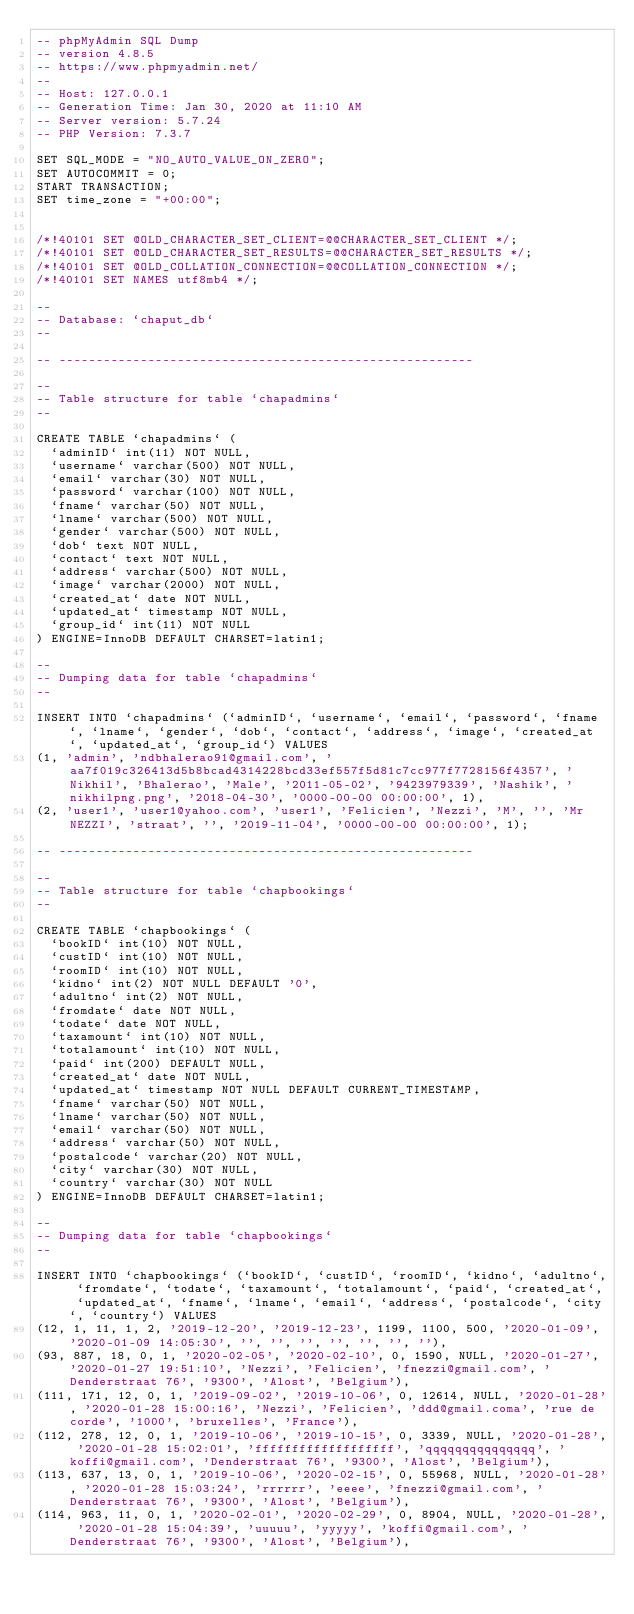<code> <loc_0><loc_0><loc_500><loc_500><_SQL_>-- phpMyAdmin SQL Dump
-- version 4.8.5
-- https://www.phpmyadmin.net/
--
-- Host: 127.0.0.1
-- Generation Time: Jan 30, 2020 at 11:10 AM
-- Server version: 5.7.24
-- PHP Version: 7.3.7

SET SQL_MODE = "NO_AUTO_VALUE_ON_ZERO";
SET AUTOCOMMIT = 0;
START TRANSACTION;
SET time_zone = "+00:00";


/*!40101 SET @OLD_CHARACTER_SET_CLIENT=@@CHARACTER_SET_CLIENT */;
/*!40101 SET @OLD_CHARACTER_SET_RESULTS=@@CHARACTER_SET_RESULTS */;
/*!40101 SET @OLD_COLLATION_CONNECTION=@@COLLATION_CONNECTION */;
/*!40101 SET NAMES utf8mb4 */;

--
-- Database: `chaput_db`
--

-- --------------------------------------------------------

--
-- Table structure for table `chapadmins`
--

CREATE TABLE `chapadmins` (
  `adminID` int(11) NOT NULL,
  `username` varchar(500) NOT NULL,
  `email` varchar(30) NOT NULL,
  `password` varchar(100) NOT NULL,
  `fname` varchar(50) NOT NULL,
  `lname` varchar(500) NOT NULL,
  `gender` varchar(500) NOT NULL,
  `dob` text NOT NULL,
  `contact` text NOT NULL,
  `address` varchar(500) NOT NULL,
  `image` varchar(2000) NOT NULL,
  `created_at` date NOT NULL,
  `updated_at` timestamp NOT NULL,
  `group_id` int(11) NOT NULL
) ENGINE=InnoDB DEFAULT CHARSET=latin1;

--
-- Dumping data for table `chapadmins`
--

INSERT INTO `chapadmins` (`adminID`, `username`, `email`, `password`, `fname`, `lname`, `gender`, `dob`, `contact`, `address`, `image`, `created_at`, `updated_at`, `group_id`) VALUES
(1, 'admin', 'ndbhalerao91@gmail.com', 'aa7f019c326413d5b8bcad4314228bcd33ef557f5d81c7cc977f7728156f4357', 'Nikhil', 'Bhalerao', 'Male', '2011-05-02', '9423979339', 'Nashik', 'nikhilpng.png', '2018-04-30', '0000-00-00 00:00:00', 1),
(2, 'user1', 'user1@yahoo.com', 'user1', 'Felicien', 'Nezzi', 'M', '', 'Mr NEZZI', 'straat', '', '2019-11-04', '0000-00-00 00:00:00', 1);

-- --------------------------------------------------------

--
-- Table structure for table `chapbookings`
--

CREATE TABLE `chapbookings` (
  `bookID` int(10) NOT NULL,
  `custID` int(10) NOT NULL,
  `roomID` int(10) NOT NULL,
  `kidno` int(2) NOT NULL DEFAULT '0',
  `adultno` int(2) NOT NULL,
  `fromdate` date NOT NULL,
  `todate` date NOT NULL,
  `taxamount` int(10) NOT NULL,
  `totalamount` int(10) NOT NULL,
  `paid` int(200) DEFAULT NULL,
  `created_at` date NOT NULL,
  `updated_at` timestamp NOT NULL DEFAULT CURRENT_TIMESTAMP,
  `fname` varchar(50) NOT NULL,
  `lname` varchar(50) NOT NULL,
  `email` varchar(50) NOT NULL,
  `address` varchar(50) NOT NULL,
  `postalcode` varchar(20) NOT NULL,
  `city` varchar(30) NOT NULL,
  `country` varchar(30) NOT NULL
) ENGINE=InnoDB DEFAULT CHARSET=latin1;

--
-- Dumping data for table `chapbookings`
--

INSERT INTO `chapbookings` (`bookID`, `custID`, `roomID`, `kidno`, `adultno`, `fromdate`, `todate`, `taxamount`, `totalamount`, `paid`, `created_at`, `updated_at`, `fname`, `lname`, `email`, `address`, `postalcode`, `city`, `country`) VALUES
(12, 1, 11, 1, 2, '2019-12-20', '2019-12-23', 1199, 1100, 500, '2020-01-09', '2020-01-09 14:05:30', '', '', '', '', '', '', ''),
(93, 887, 18, 0, 1, '2020-02-05', '2020-02-10', 0, 1590, NULL, '2020-01-27', '2020-01-27 19:51:10', 'Nezzi', 'Felicien', 'fnezzi@gmail.com', 'Denderstraat 76', '9300', 'Alost', 'Belgium'),
(111, 171, 12, 0, 1, '2019-09-02', '2019-10-06', 0, 12614, NULL, '2020-01-28', '2020-01-28 15:00:16', 'Nezzi', 'Felicien', 'ddd@gmail.coma', 'rue de corde', '1000', 'bruxelles', 'France'),
(112, 278, 12, 0, 1, '2019-10-06', '2019-10-15', 0, 3339, NULL, '2020-01-28', '2020-01-28 15:02:01', 'fffffffffffffffffff', 'qqqqqqqqqqqqqqq', 'koffi@gmail.com', 'Denderstraat 76', '9300', 'Alost', 'Belgium'),
(113, 637, 13, 0, 1, '2019-10-06', '2020-02-15', 0, 55968, NULL, '2020-01-28', '2020-01-28 15:03:24', 'rrrrrr', 'eeee', 'fnezzi@gmail.com', 'Denderstraat 76', '9300', 'Alost', 'Belgium'),
(114, 963, 11, 0, 1, '2020-02-01', '2020-02-29', 0, 8904, NULL, '2020-01-28', '2020-01-28 15:04:39', 'uuuuu', 'yyyyy', 'koffi@gmail.com', 'Denderstraat 76', '9300', 'Alost', 'Belgium'),</code> 